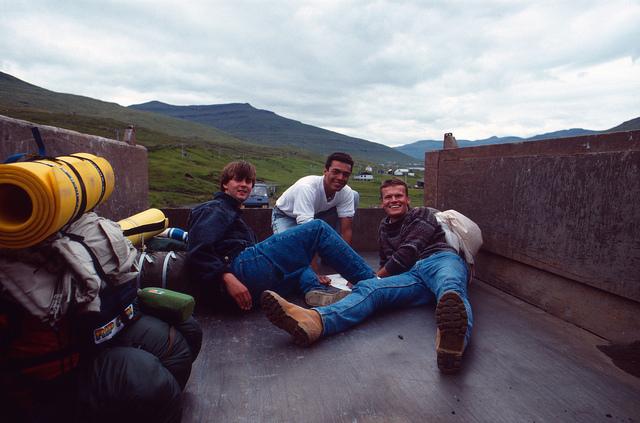Are the people sitting on chairs?
Give a very brief answer. No. Are they camping?
Quick response, please. Yes. What is the person in blue doing?
Be succinct. Sitting. How many men are there?
Keep it brief. 3. 